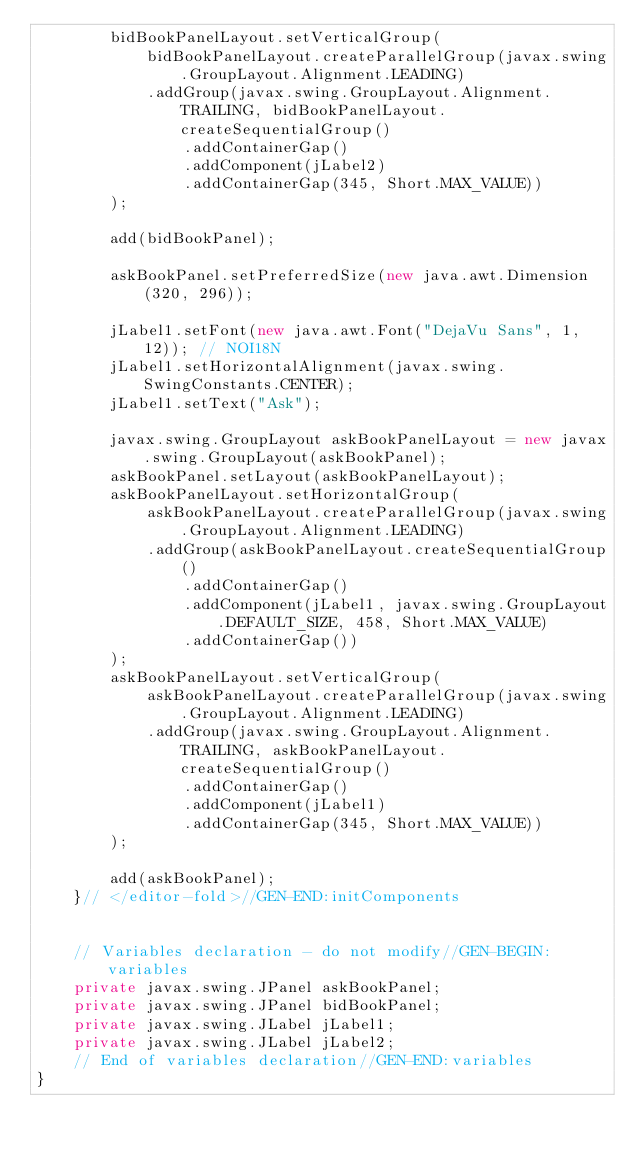<code> <loc_0><loc_0><loc_500><loc_500><_Java_>        bidBookPanelLayout.setVerticalGroup(
            bidBookPanelLayout.createParallelGroup(javax.swing.GroupLayout.Alignment.LEADING)
            .addGroup(javax.swing.GroupLayout.Alignment.TRAILING, bidBookPanelLayout.createSequentialGroup()
                .addContainerGap()
                .addComponent(jLabel2)
                .addContainerGap(345, Short.MAX_VALUE))
        );

        add(bidBookPanel);

        askBookPanel.setPreferredSize(new java.awt.Dimension(320, 296));

        jLabel1.setFont(new java.awt.Font("DejaVu Sans", 1, 12)); // NOI18N
        jLabel1.setHorizontalAlignment(javax.swing.SwingConstants.CENTER);
        jLabel1.setText("Ask");

        javax.swing.GroupLayout askBookPanelLayout = new javax.swing.GroupLayout(askBookPanel);
        askBookPanel.setLayout(askBookPanelLayout);
        askBookPanelLayout.setHorizontalGroup(
            askBookPanelLayout.createParallelGroup(javax.swing.GroupLayout.Alignment.LEADING)
            .addGroup(askBookPanelLayout.createSequentialGroup()
                .addContainerGap()
                .addComponent(jLabel1, javax.swing.GroupLayout.DEFAULT_SIZE, 458, Short.MAX_VALUE)
                .addContainerGap())
        );
        askBookPanelLayout.setVerticalGroup(
            askBookPanelLayout.createParallelGroup(javax.swing.GroupLayout.Alignment.LEADING)
            .addGroup(javax.swing.GroupLayout.Alignment.TRAILING, askBookPanelLayout.createSequentialGroup()
                .addContainerGap()
                .addComponent(jLabel1)
                .addContainerGap(345, Short.MAX_VALUE))
        );

        add(askBookPanel);
    }// </editor-fold>//GEN-END:initComponents


    // Variables declaration - do not modify//GEN-BEGIN:variables
    private javax.swing.JPanel askBookPanel;
    private javax.swing.JPanel bidBookPanel;
    private javax.swing.JLabel jLabel1;
    private javax.swing.JLabel jLabel2;
    // End of variables declaration//GEN-END:variables
}
</code> 